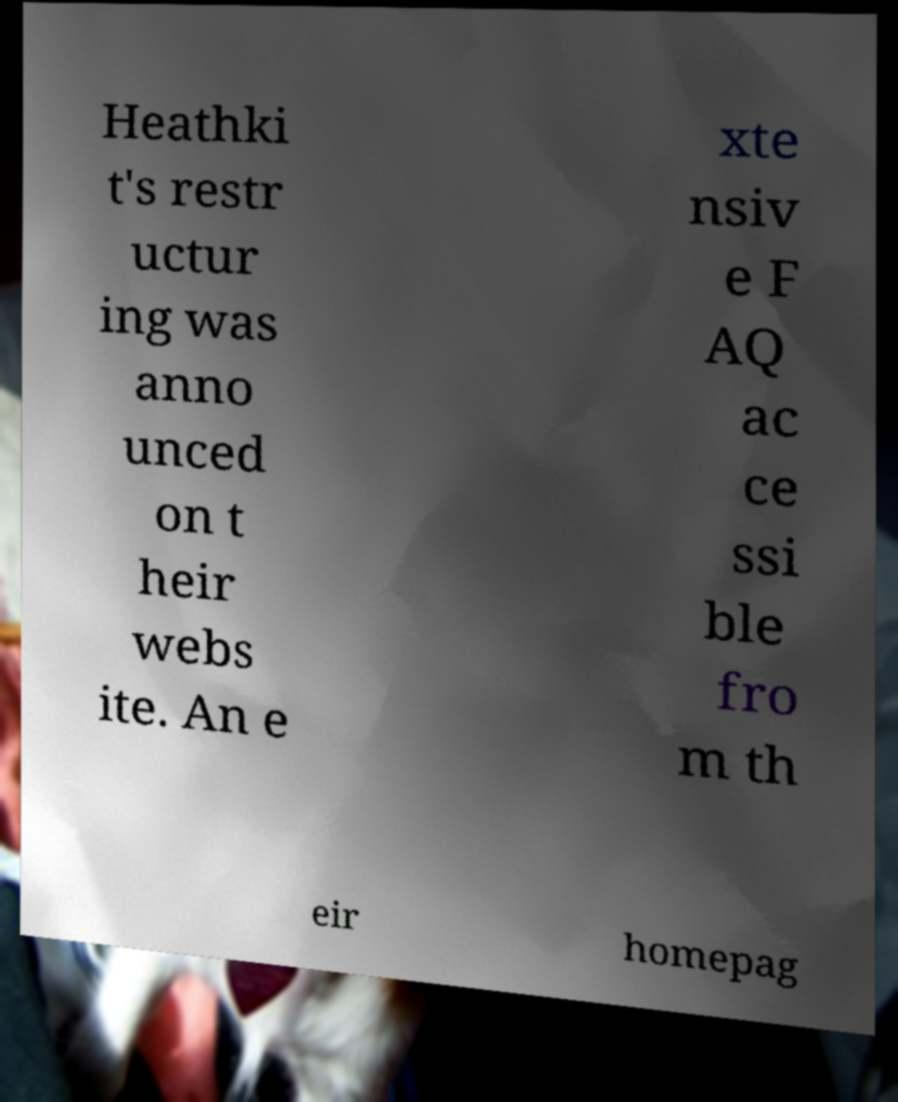Can you read and provide the text displayed in the image?This photo seems to have some interesting text. Can you extract and type it out for me? Heathki t's restr uctur ing was anno unced on t heir webs ite. An e xte nsiv e F AQ ac ce ssi ble fro m th eir homepag 